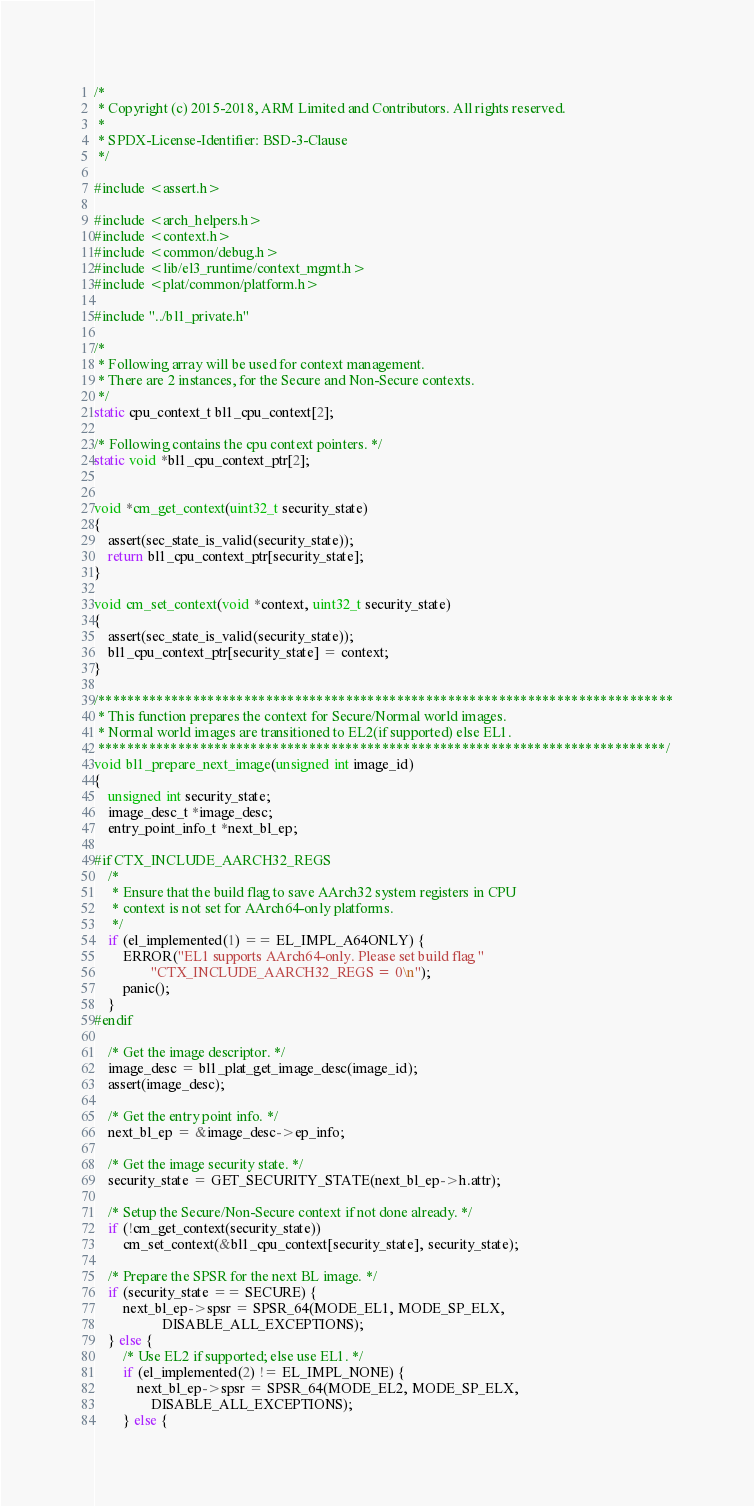<code> <loc_0><loc_0><loc_500><loc_500><_C_>/*
 * Copyright (c) 2015-2018, ARM Limited and Contributors. All rights reserved.
 *
 * SPDX-License-Identifier: BSD-3-Clause
 */

#include <assert.h>

#include <arch_helpers.h>
#include <context.h>
#include <common/debug.h>
#include <lib/el3_runtime/context_mgmt.h>
#include <plat/common/platform.h>

#include "../bl1_private.h"

/*
 * Following array will be used for context management.
 * There are 2 instances, for the Secure and Non-Secure contexts.
 */
static cpu_context_t bl1_cpu_context[2];

/* Following contains the cpu context pointers. */
static void *bl1_cpu_context_ptr[2];


void *cm_get_context(uint32_t security_state)
{
	assert(sec_state_is_valid(security_state));
	return bl1_cpu_context_ptr[security_state];
}

void cm_set_context(void *context, uint32_t security_state)
{
	assert(sec_state_is_valid(security_state));
	bl1_cpu_context_ptr[security_state] = context;
}

/*******************************************************************************
 * This function prepares the context for Secure/Normal world images.
 * Normal world images are transitioned to EL2(if supported) else EL1.
 ******************************************************************************/
void bl1_prepare_next_image(unsigned int image_id)
{
	unsigned int security_state;
	image_desc_t *image_desc;
	entry_point_info_t *next_bl_ep;

#if CTX_INCLUDE_AARCH32_REGS
	/*
	 * Ensure that the build flag to save AArch32 system registers in CPU
	 * context is not set for AArch64-only platforms.
	 */
	if (el_implemented(1) == EL_IMPL_A64ONLY) {
		ERROR("EL1 supports AArch64-only. Please set build flag "
				"CTX_INCLUDE_AARCH32_REGS = 0\n");
		panic();
	}
#endif

	/* Get the image descriptor. */
	image_desc = bl1_plat_get_image_desc(image_id);
	assert(image_desc);

	/* Get the entry point info. */
	next_bl_ep = &image_desc->ep_info;

	/* Get the image security state. */
	security_state = GET_SECURITY_STATE(next_bl_ep->h.attr);

	/* Setup the Secure/Non-Secure context if not done already. */
	if (!cm_get_context(security_state))
		cm_set_context(&bl1_cpu_context[security_state], security_state);

	/* Prepare the SPSR for the next BL image. */
	if (security_state == SECURE) {
		next_bl_ep->spsr = SPSR_64(MODE_EL1, MODE_SP_ELX,
				   DISABLE_ALL_EXCEPTIONS);
	} else {
		/* Use EL2 if supported; else use EL1. */
		if (el_implemented(2) != EL_IMPL_NONE) {
			next_bl_ep->spsr = SPSR_64(MODE_EL2, MODE_SP_ELX,
				DISABLE_ALL_EXCEPTIONS);
		} else {</code> 